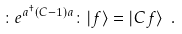<formula> <loc_0><loc_0><loc_500><loc_500>\colon e ^ { a ^ { \dagger } ( C - 1 ) a } \colon | f \rangle = | C f \rangle \ .</formula> 